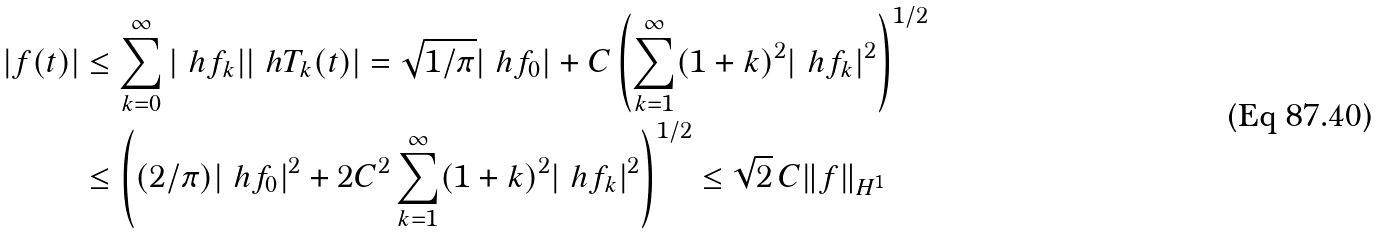Convert formula to latex. <formula><loc_0><loc_0><loc_500><loc_500>| f ( t ) | & \leq \sum _ { k = 0 } ^ { \infty } | \ h f _ { k } | | \ h T _ { k } ( t ) | = \sqrt { 1 / \pi } | \ h f _ { 0 } | + C \left ( \sum _ { k = 1 } ^ { \infty } ( 1 + k ) ^ { 2 } | \ h f _ { k } | ^ { 2 } \right ) ^ { 1 / 2 } \\ & \leq \left ( ( 2 / \pi ) | \ h f _ { 0 } | ^ { 2 } + 2 C ^ { 2 } \sum _ { k = 1 } ^ { \infty } ( 1 + k ) ^ { 2 } | \ h f _ { k } | ^ { 2 } \right ) ^ { 1 / 2 } \leq \sqrt { 2 } \, C \| f \| _ { H ^ { 1 } }</formula> 